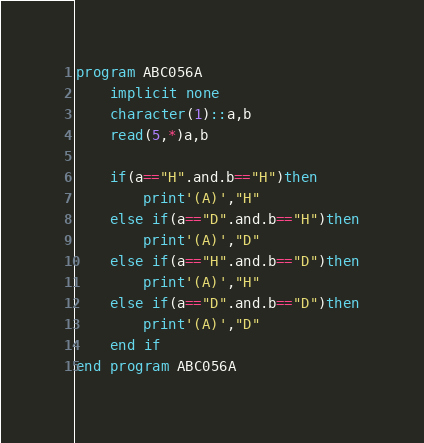<code> <loc_0><loc_0><loc_500><loc_500><_FORTRAN_>program ABC056A
    implicit none
    character(1)::a,b
    read(5,*)a,b

    if(a=="H".and.b=="H")then
        print'(A)',"H"
    else if(a=="D".and.b=="H")then
        print'(A)',"D"
    else if(a=="H".and.b=="D")then
        print'(A)',"H"
    else if(a=="D".and.b=="D")then
        print'(A)',"D"
    end if
end program ABC056A</code> 